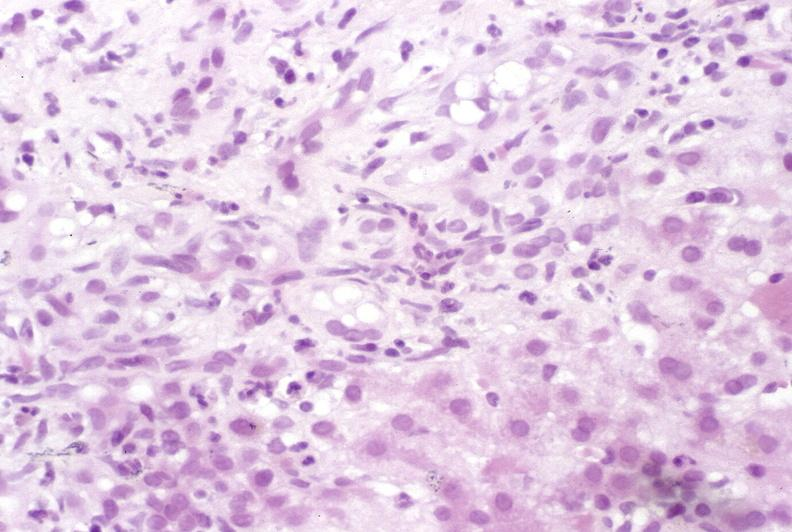does myocardium show primary sclerosing cholangitis?
Answer the question using a single word or phrase. No 